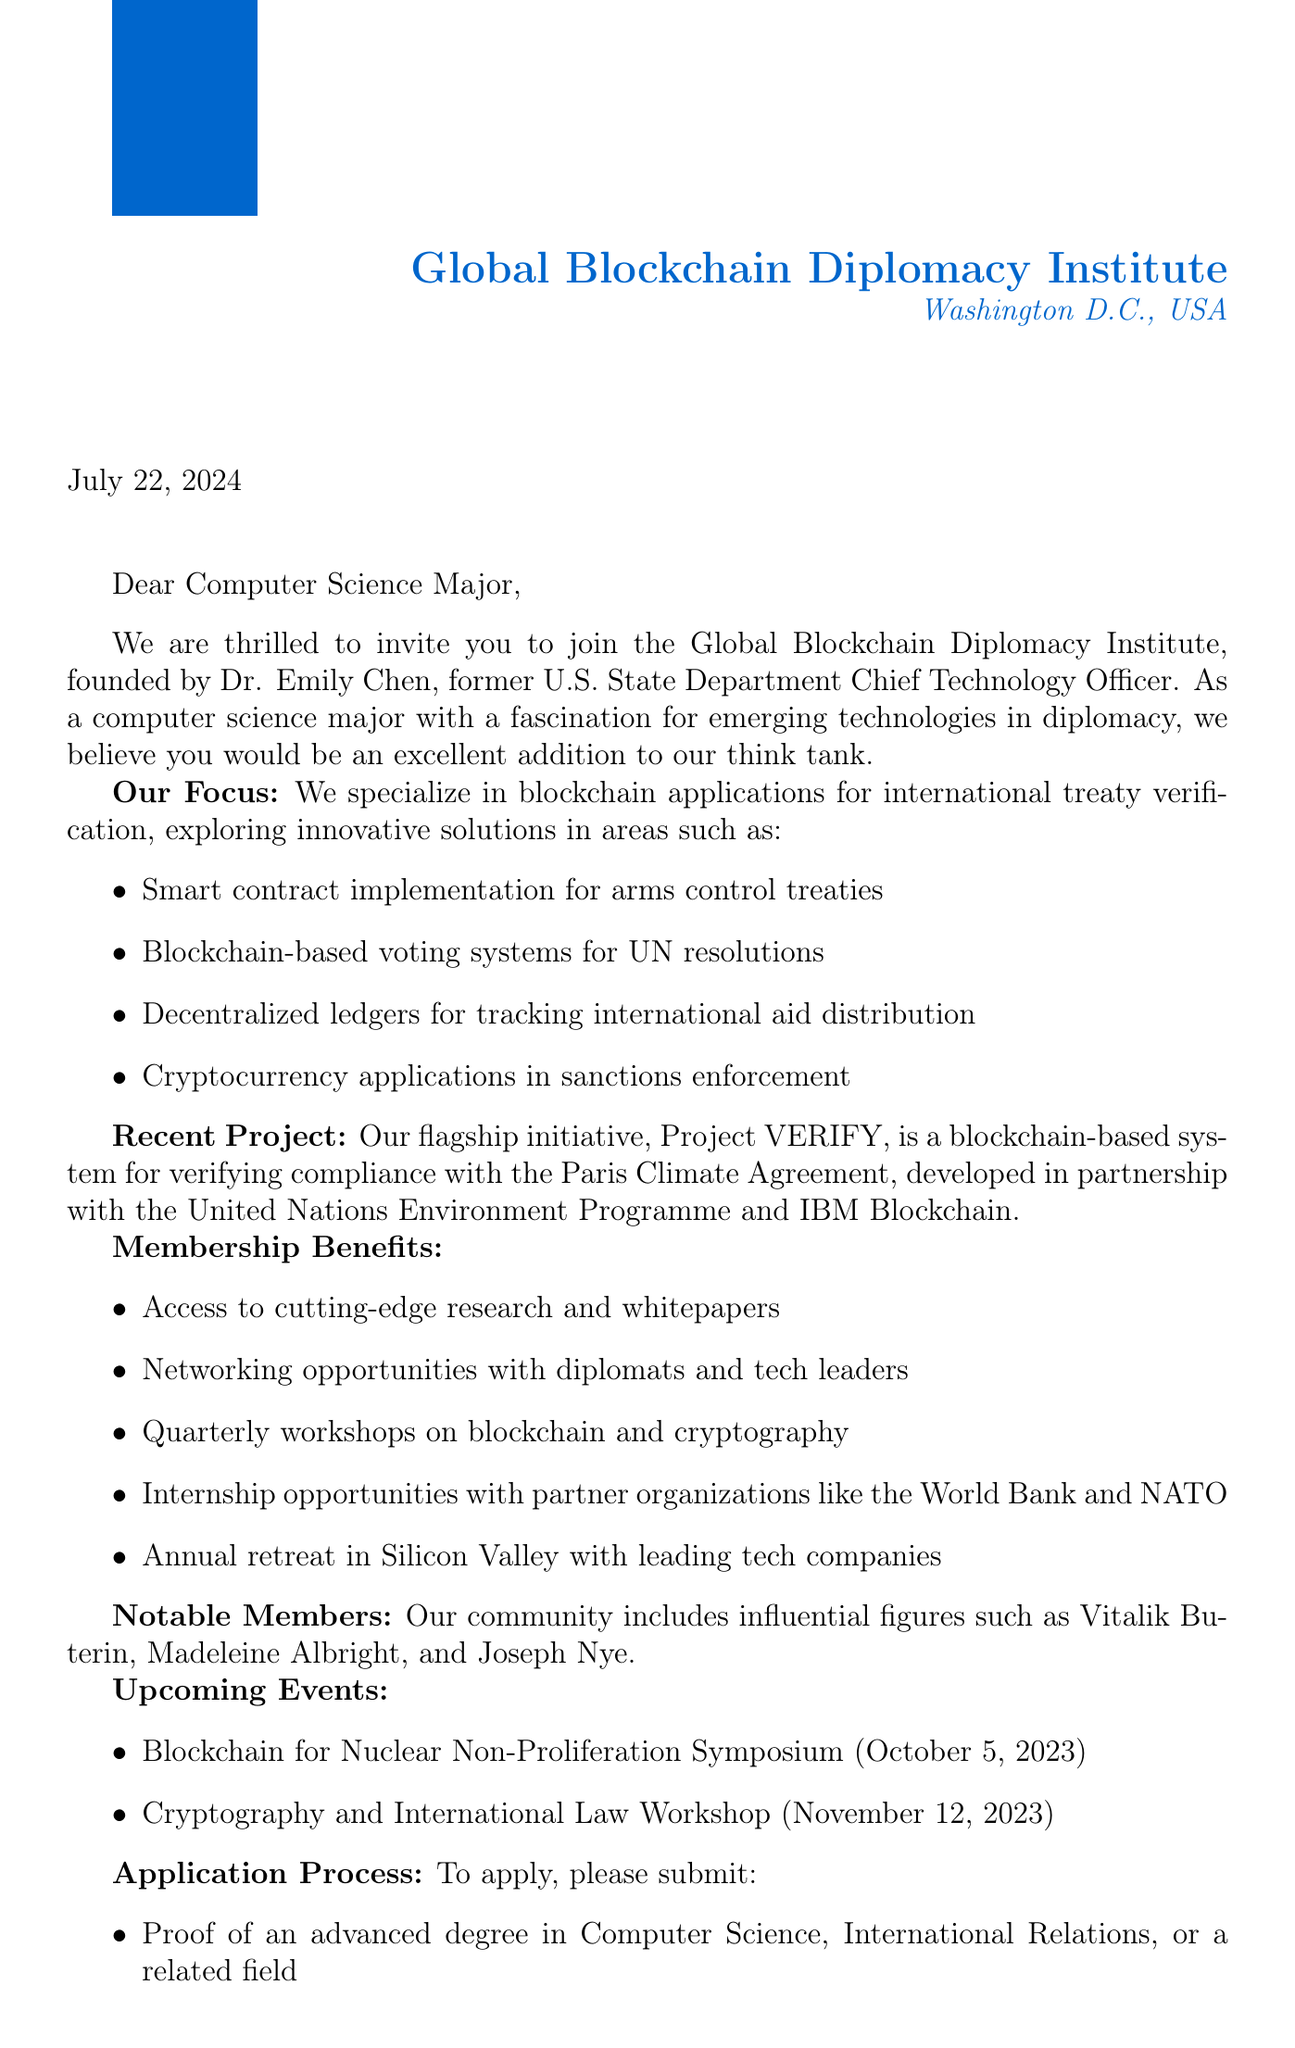What is the name of the think tank? The document states the think tank is called the Global Blockchain Diplomacy Institute.
Answer: Global Blockchain Diplomacy Institute Who is the founder of the think tank? According to the document, the founder is Dr. Emily Chen.
Answer: Dr. Emily Chen When does the Annual Emerging Technologies in Diplomacy Conference take place? The document specifies that the conference is held from September 15-17, 2023.
Answer: September 15-17, 2023 What is the recent project mentioned in the document? The document highlights Project VERIFY as the recent project.
Answer: Project VERIFY What is one of the membership benefits? The document lists several benefits, including access to cutting-edge research and whitepapers.
Answer: Access to cutting-edge research and whitepapers What are applicants required to submit along with their application? Per the document, applicants must submit two letters of recommendation from academic or professional references.
Answer: Two letters of recommendation Which notable member is a co-founder of Ethereum? The document states that Vitalik Buterin is a notable member.
Answer: Vitalik Buterin What type of event is scheduled for October 5, 2023? The document specifies that a symposium titled "Blockchain for Nuclear Non-Proliferation" is scheduled for that date.
Answer: Blockchain for Nuclear Non-Proliferation Symposium How many focus areas are mentioned in the document? The document lists four focus areas related to blockchain applications in diplomacy.
Answer: Four 